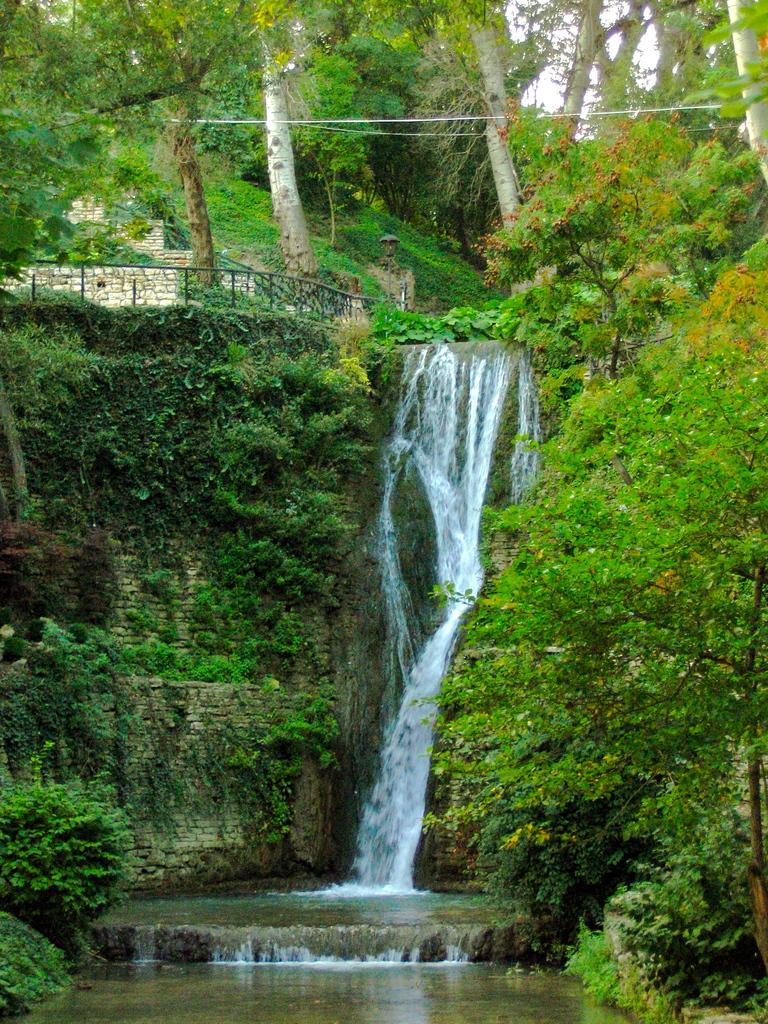What natural feature is the main subject of the image? There is a waterfall in the image. What other natural elements can be seen in the image? There are plants and trees in the image. What man-made object is present in the image? There is a metal railing in the image. What is visible in the background of the image? The sky is visible in the image. Can you see your friends working in the office in the image? There is no office or friends present in the image; it features a waterfall, plants, trees, a metal railing, and the sky. 